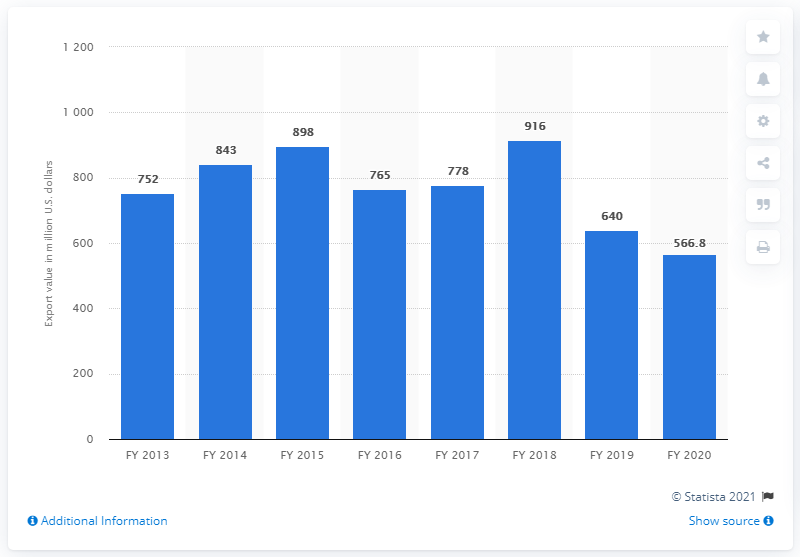Mention a couple of crucial points in this snapshot. In the fiscal year 2020, the exports of cashews from India totaled 566.8 million dollars. 